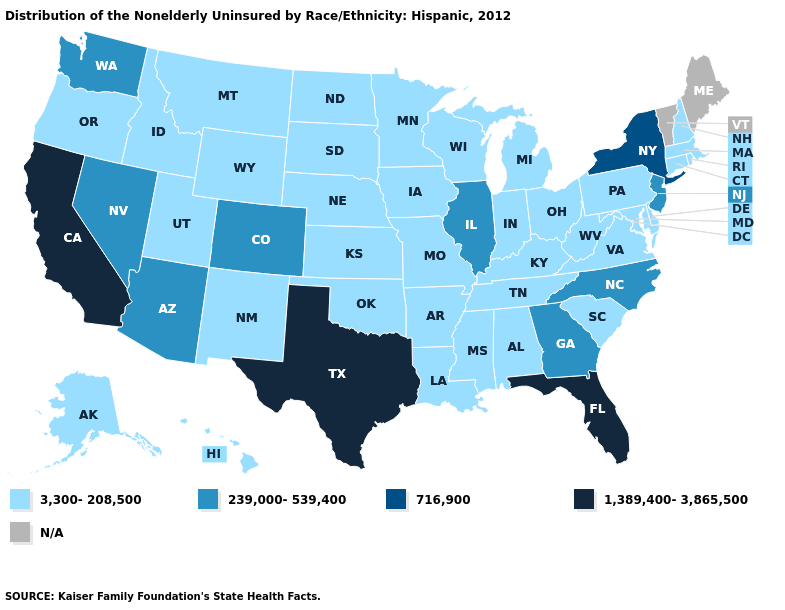Does the map have missing data?
Be succinct. Yes. What is the highest value in the USA?
Keep it brief. 1,389,400-3,865,500. Which states have the highest value in the USA?
Give a very brief answer. California, Florida, Texas. What is the value of North Dakota?
Keep it brief. 3,300-208,500. Name the states that have a value in the range 3,300-208,500?
Answer briefly. Alabama, Alaska, Arkansas, Connecticut, Delaware, Hawaii, Idaho, Indiana, Iowa, Kansas, Kentucky, Louisiana, Maryland, Massachusetts, Michigan, Minnesota, Mississippi, Missouri, Montana, Nebraska, New Hampshire, New Mexico, North Dakota, Ohio, Oklahoma, Oregon, Pennsylvania, Rhode Island, South Carolina, South Dakota, Tennessee, Utah, Virginia, West Virginia, Wisconsin, Wyoming. What is the value of Alaska?
Concise answer only. 3,300-208,500. What is the value of Michigan?
Keep it brief. 3,300-208,500. Among the states that border Wyoming , which have the lowest value?
Short answer required. Idaho, Montana, Nebraska, South Dakota, Utah. What is the highest value in the USA?
Be succinct. 1,389,400-3,865,500. Among the states that border New Mexico , does Arizona have the lowest value?
Write a very short answer. No. Which states hav the highest value in the Northeast?
Write a very short answer. New York. What is the value of Pennsylvania?
Answer briefly. 3,300-208,500. 